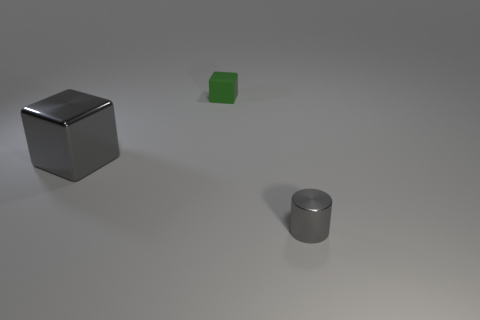Are there any other things that have the same material as the tiny green cube?
Your answer should be very brief. No. How many things are either small gray cylinders or tiny green rubber objects?
Make the answer very short. 2. What is the shape of the thing that is both in front of the green block and right of the big gray metal block?
Provide a succinct answer. Cylinder. Is the cube that is on the left side of the green matte cube made of the same material as the small cube?
Keep it short and to the point. No. How many things are gray shiny cylinders or metallic things right of the green matte block?
Provide a succinct answer. 1. There is a tiny thing that is made of the same material as the big gray object; what is its color?
Offer a terse response. Gray. What number of other big blue things have the same material as the large object?
Your answer should be very brief. 0. How many tiny gray metallic things are there?
Keep it short and to the point. 1. There is a metallic thing that is left of the small cylinder; does it have the same color as the tiny thing in front of the metal block?
Keep it short and to the point. Yes. What number of green objects are behind the large gray shiny cube?
Make the answer very short. 1. 